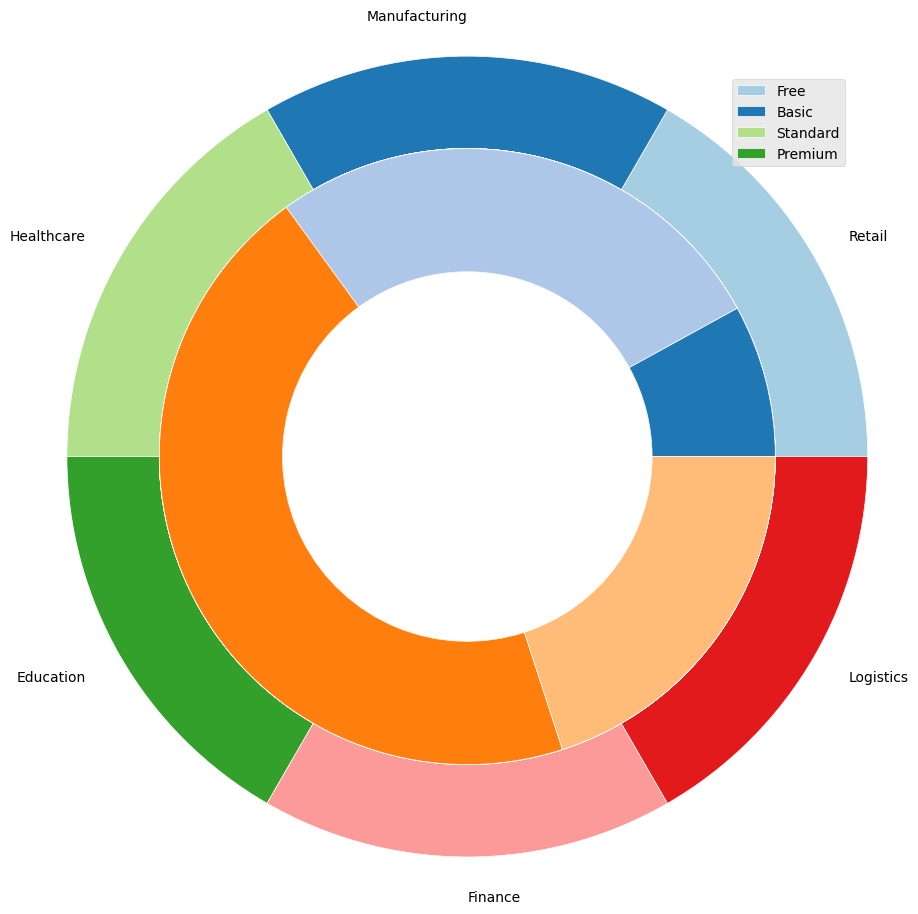Which industry has the largest overall adoption of cloud software solutions? By looking at the outer pie chart, the segment with the largest size corresponds to the industry with the highest overall adoption. The size of the segments indicates that the largest adoption belongs to the Retail sector.
Answer: Retail In the Finance industry, which subscription tier has the highest adoption? Referring to the inner pie segment within the Finance sector (shown in outer pie), the sector with the largest segment here indicates the highest adoption tier. Finance's largest segment is the Standard tier.
Answer: Standard Comparing Manufacturing and Logistics, which industry has a higher percentage of Standard tier subscriptions? Inspecting the inner pie segments for both Manufacturing and Logistics sectors, the Standard tier segment within Manufacturing is smaller compared to Logistics.
Answer: Logistics For the Education industry, what is the total percentage of Basic and Premium subscriptions combined? The Basic subscription is at 30%, and the Premium subscription is at 25%. Adding these two gives a total of 30% + 25%.
Answer: 55% Within the Retail sector, which subscription tier is adopted less than the Standard tier but more than the Basic tier? In the Retail sector, comparing the segments, the Standard tier is 30%, the tiers that fit the condition are Premium (35%) and Basic (20%), so it must be Premium.
Answer: Premium Is the percentage of Free subscriptions in the Logistics industry greater than or less than the corresponding percentage in the Healthcare industry? The inner pie segments for Free subscriptions are 8% for Logistics and 12% for Healthcare. The segment for Logistics is smaller than Healthcare.
Answer: Less What is the difference in the total percentage of cloud software adoption between the Healthcare and Finance industries? The outer pie sizes show that Healthcare's total percentage is 100% (sum of its segments) and Finance's also sums up to 100%. Therefore, the difference is 100% - 100%.
Answer: 0% Which subscription tier in the Healthcare sector has the least adoption, and what is that percentage? By inspecting the inner pie segments within the Healthcare sector's outer pie, the Free tier has the smallest segment at 12%.
Answer: Free, 12% If you combine the Basic subscriptions from Manufacturing and Retail, how does this compare to the combined Basic subscriptions from Finance and Education? Manufacturing Basic is 25% + Retail Basic is 20% = 45%. Finance Basic is 20% + Education Basic is 30% = 50%. Comparing 45% to 50%, Finance and Education are higher.
Answer: Finance and Education are higher Considering all industries, which single subscription tier (across any industry) has the highest adoption? By evaluating all the inner pie segments, the largest single segment across any industry is the Standard tier in the Logistics sector with 45%.
Answer: Standard in Logistics 